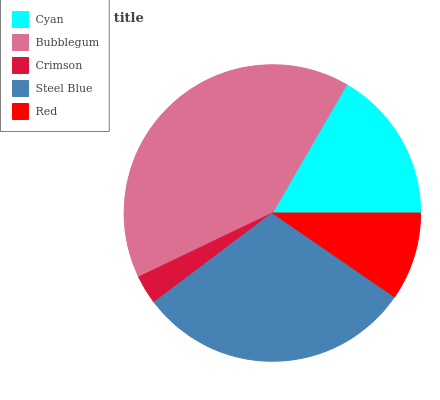Is Crimson the minimum?
Answer yes or no. Yes. Is Bubblegum the maximum?
Answer yes or no. Yes. Is Bubblegum the minimum?
Answer yes or no. No. Is Crimson the maximum?
Answer yes or no. No. Is Bubblegum greater than Crimson?
Answer yes or no. Yes. Is Crimson less than Bubblegum?
Answer yes or no. Yes. Is Crimson greater than Bubblegum?
Answer yes or no. No. Is Bubblegum less than Crimson?
Answer yes or no. No. Is Cyan the high median?
Answer yes or no. Yes. Is Cyan the low median?
Answer yes or no. Yes. Is Steel Blue the high median?
Answer yes or no. No. Is Steel Blue the low median?
Answer yes or no. No. 